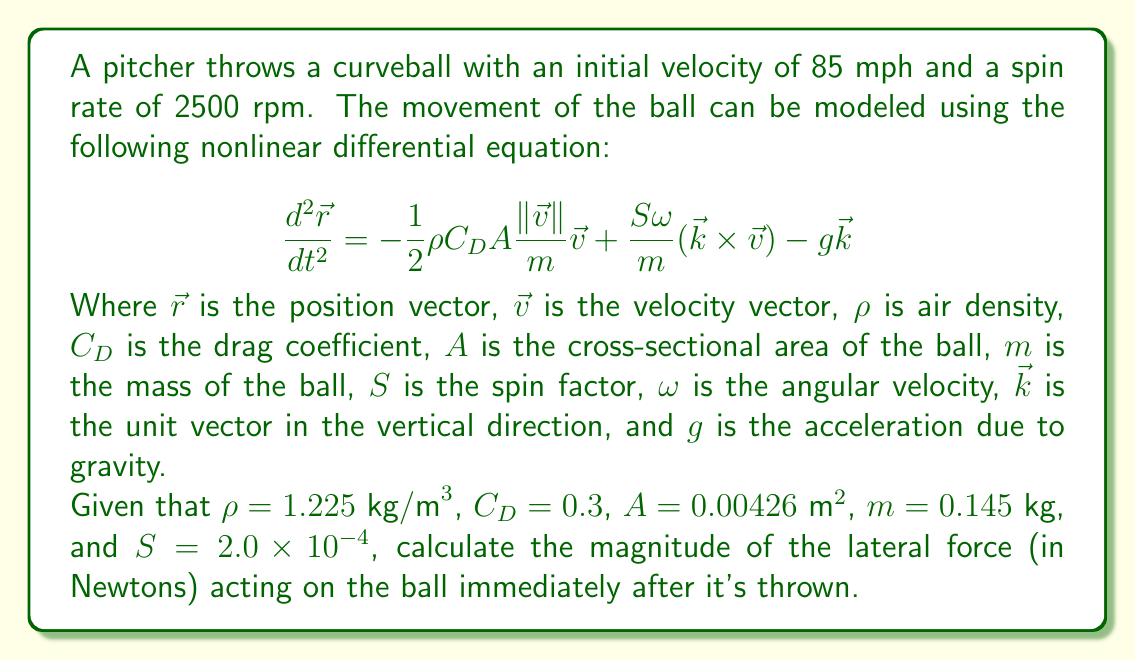Teach me how to tackle this problem. To solve this problem, we need to focus on the term in the equation that represents the Magnus force, which is responsible for the lateral movement of the ball:

$$\frac{S\omega}{m}(\vec{k} \times \vec{v})$$

Let's break down the solution into steps:

1) First, we need to convert the given values to SI units:
   - Initial velocity: 85 mph = 37.95 m/s
   - Spin rate: 2500 rpm = 2500 * 2π / 60 = 261.8 rad/s

2) The magnitude of the lateral force is given by:
   $$F_{\text{lateral}} = \frac{S\omega mv}{m} = S\omega v$$

3) Substituting the values:
   $$F_{\text{lateral}} = (2.0 \times 10^{-4})(261.8)(37.95)$$

4) Calculate:
   $$F_{\text{lateral}} = 1.987 \text{ N}$$

5) Round to three significant figures:
   $$F_{\text{lateral}} \approx 1.99 \text{ N}$$

This force acts perpendicular to both the velocity and the axis of rotation, causing the curveball to deviate from its straight path.
Answer: 1.99 N 